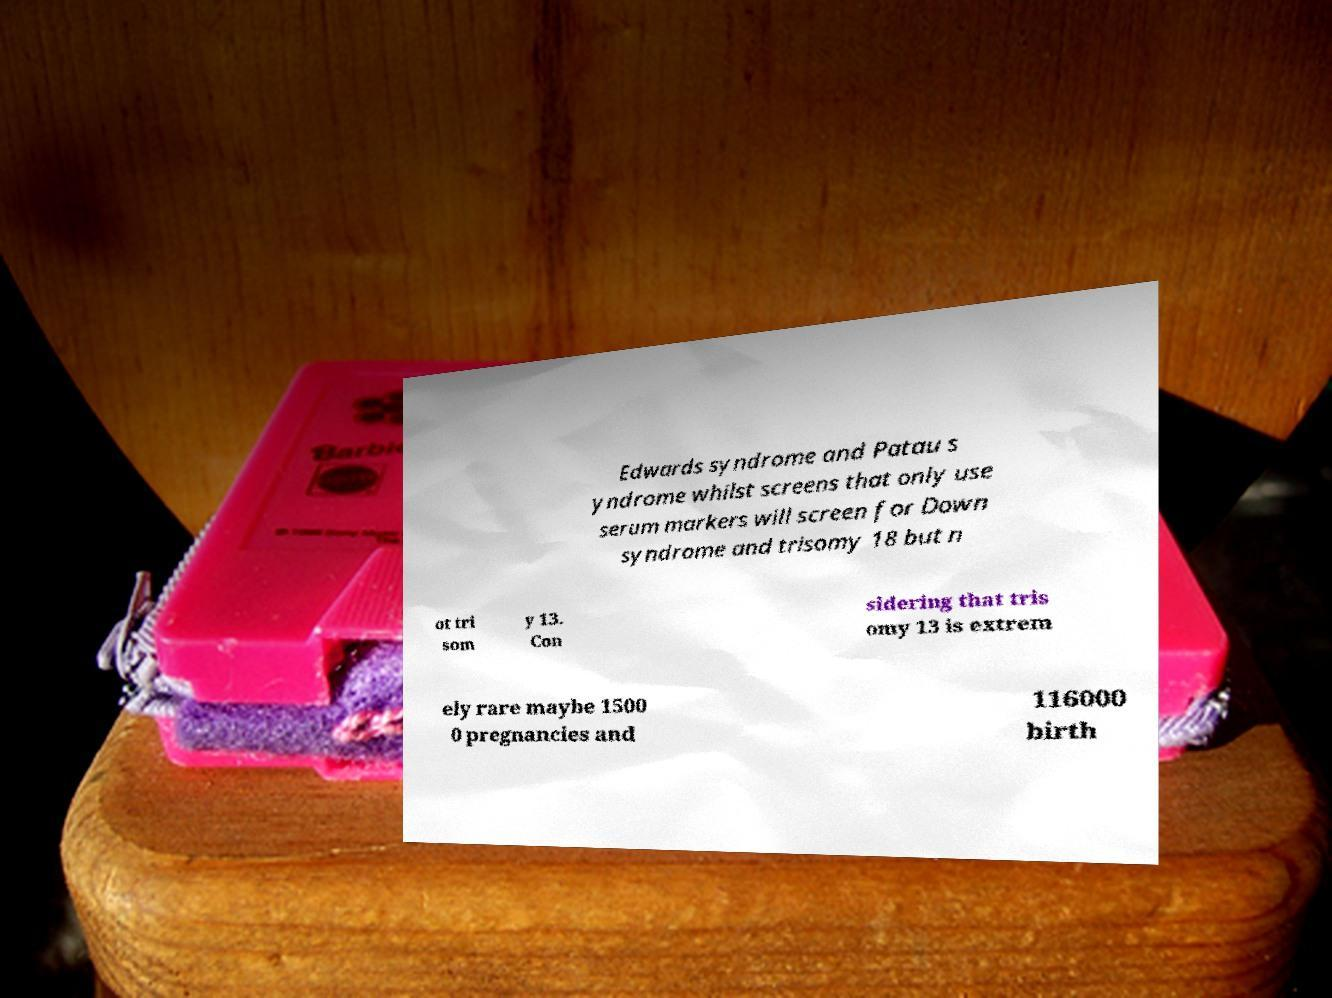Could you assist in decoding the text presented in this image and type it out clearly? Edwards syndrome and Patau s yndrome whilst screens that only use serum markers will screen for Down syndrome and trisomy 18 but n ot tri som y 13. Con sidering that tris omy 13 is extrem ely rare maybe 1500 0 pregnancies and 116000 birth 